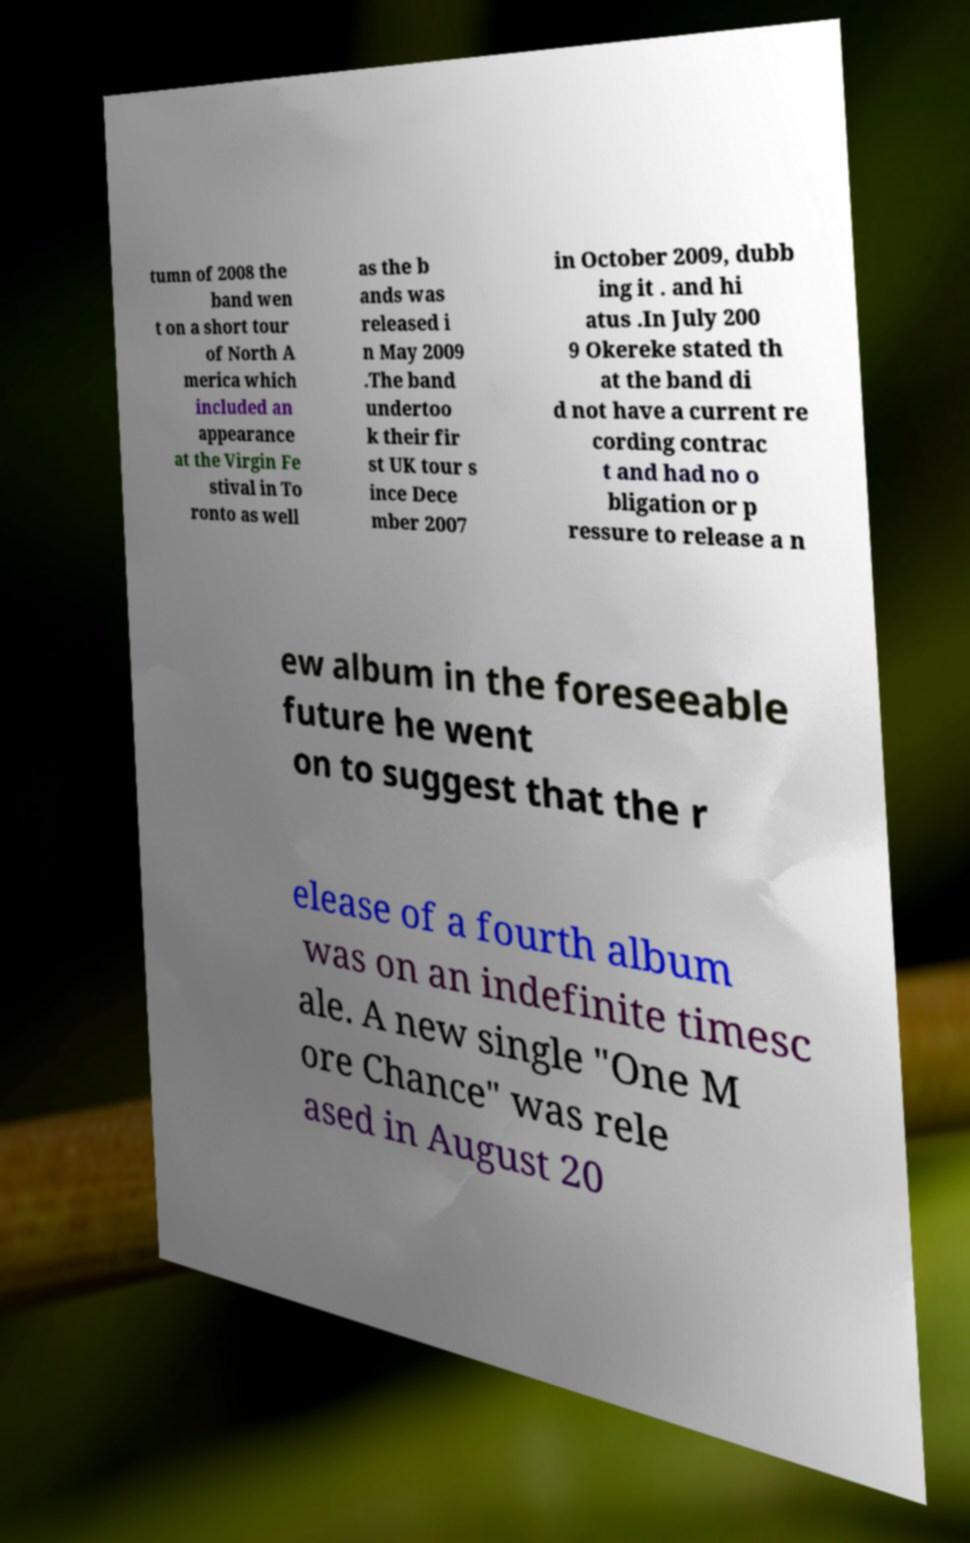Can you read and provide the text displayed in the image?This photo seems to have some interesting text. Can you extract and type it out for me? tumn of 2008 the band wen t on a short tour of North A merica which included an appearance at the Virgin Fe stival in To ronto as well as the b ands was released i n May 2009 .The band undertoo k their fir st UK tour s ince Dece mber 2007 in October 2009, dubb ing it . and hi atus .In July 200 9 Okereke stated th at the band di d not have a current re cording contrac t and had no o bligation or p ressure to release a n ew album in the foreseeable future he went on to suggest that the r elease of a fourth album was on an indefinite timesc ale. A new single "One M ore Chance" was rele ased in August 20 